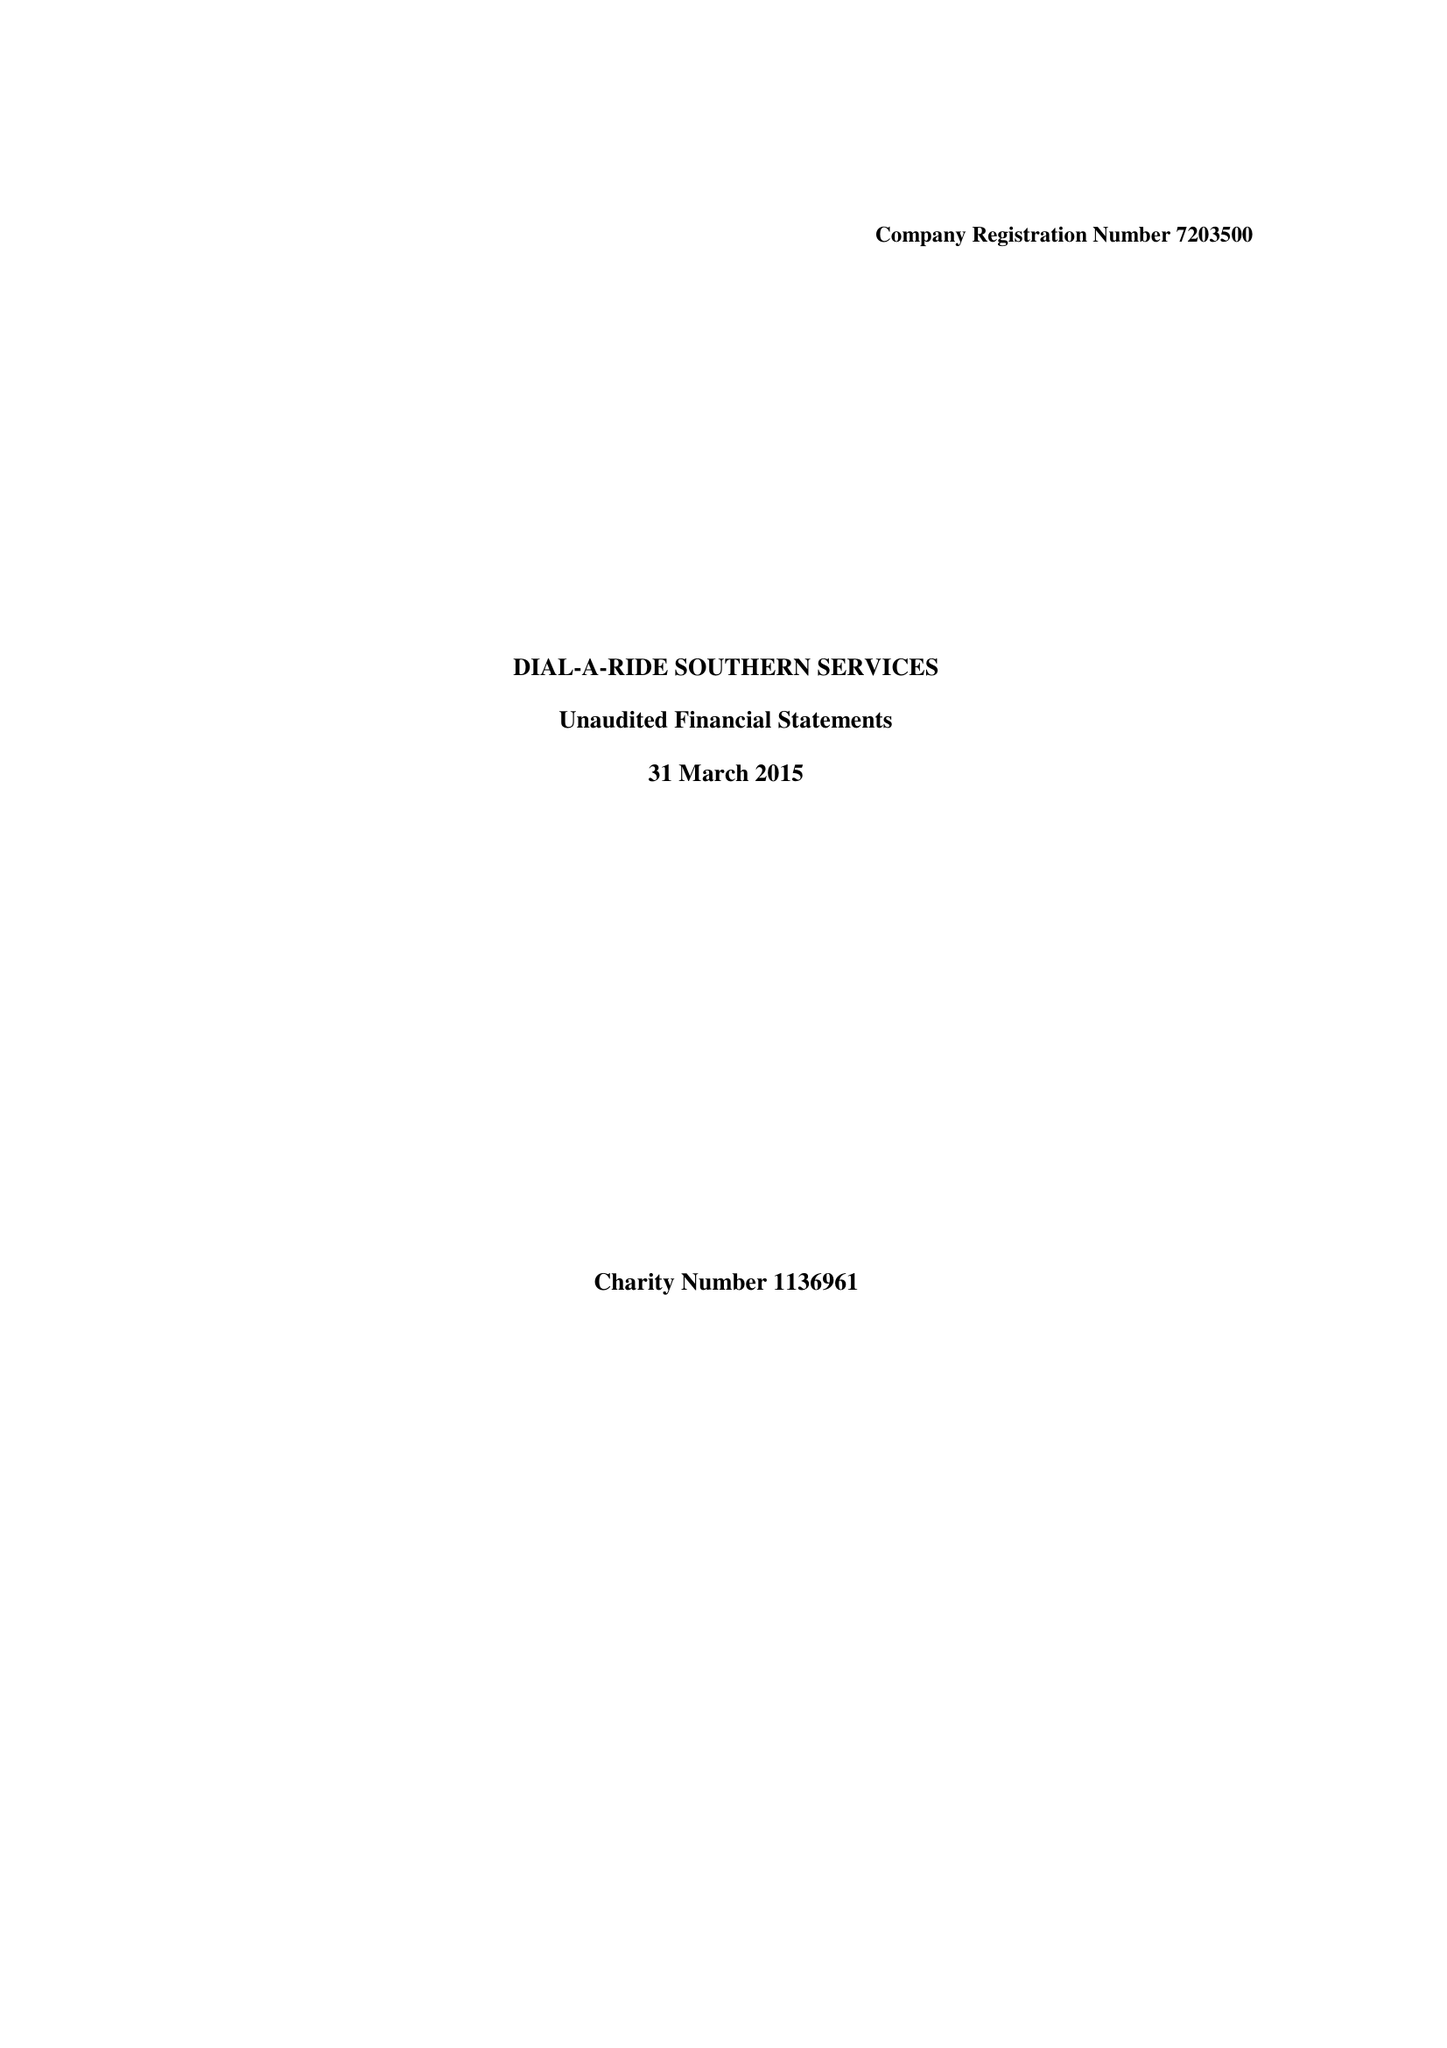What is the value for the charity_name?
Answer the question using a single word or phrase. Dial-A-Ride Southern Services 